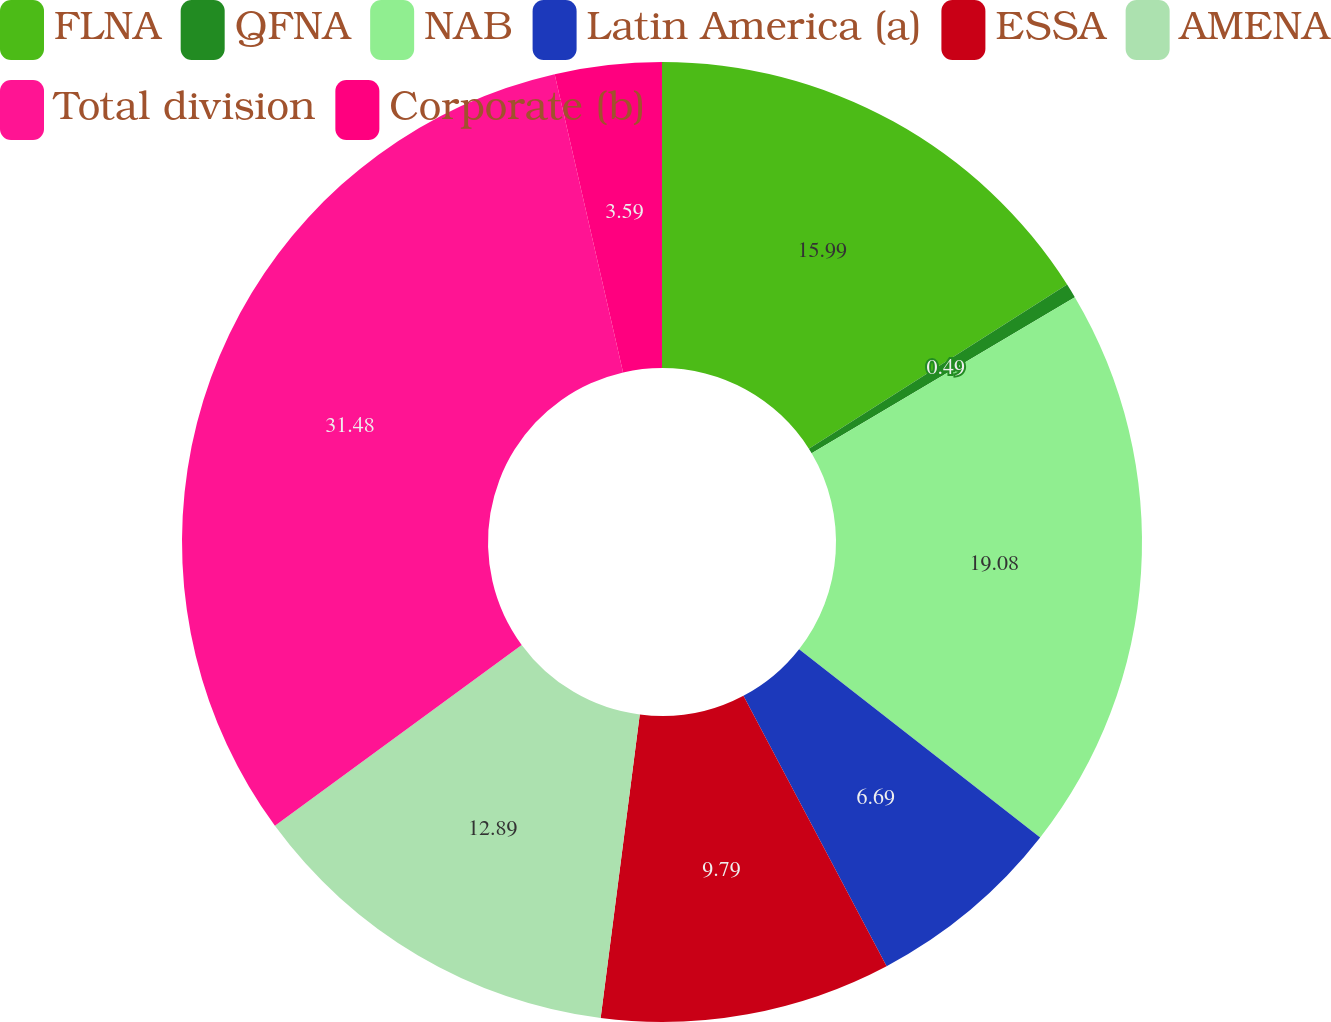<chart> <loc_0><loc_0><loc_500><loc_500><pie_chart><fcel>FLNA<fcel>QFNA<fcel>NAB<fcel>Latin America (a)<fcel>ESSA<fcel>AMENA<fcel>Total division<fcel>Corporate (b)<nl><fcel>15.99%<fcel>0.49%<fcel>19.08%<fcel>6.69%<fcel>9.79%<fcel>12.89%<fcel>31.48%<fcel>3.59%<nl></chart> 